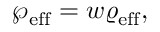<formula> <loc_0><loc_0><loc_500><loc_500>\wp _ { e f f } = w \varrho _ { e f f } ,</formula> 